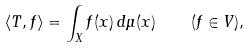Convert formula to latex. <formula><loc_0><loc_0><loc_500><loc_500>\langle T , f \rangle = \int _ { X } f ( x ) \, d \mu ( x ) \quad ( f \in V ) ,</formula> 